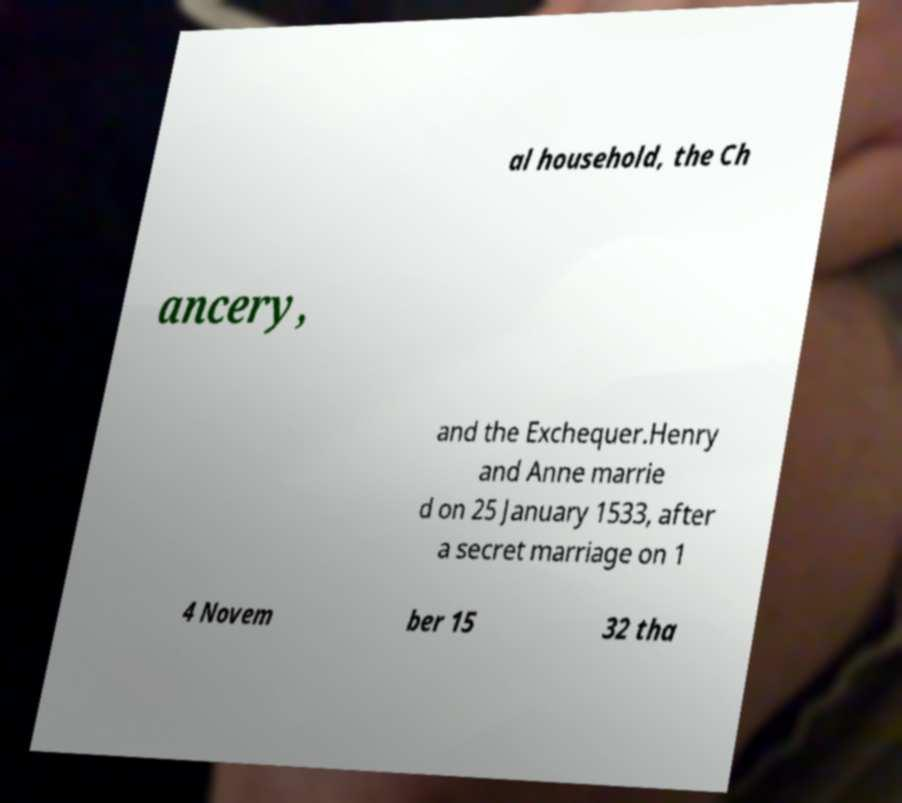Please identify and transcribe the text found in this image. al household, the Ch ancery, and the Exchequer.Henry and Anne marrie d on 25 January 1533, after a secret marriage on 1 4 Novem ber 15 32 tha 